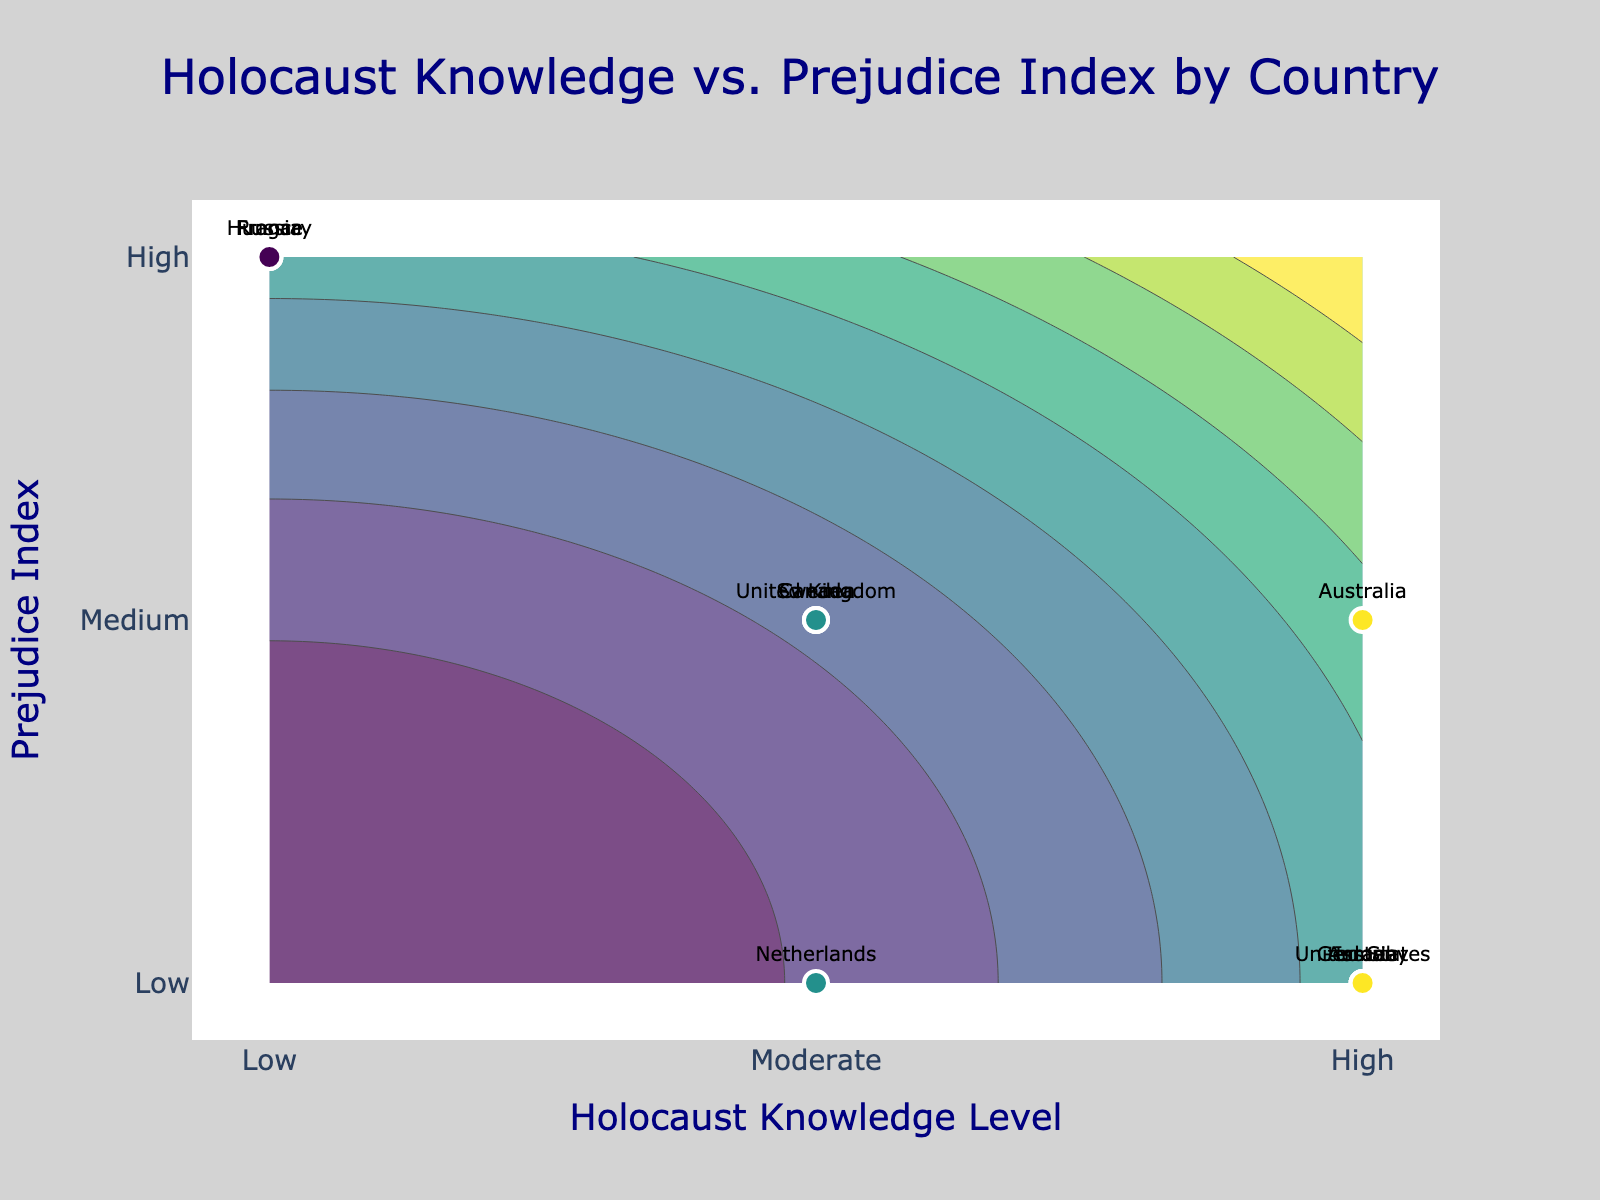What is the title of the figure? The title of the figure is shown at the top center of the plot.
Answer: Holocaust Knowledge vs. Prejudice Index by Country How many countries are displayed in the figure? Each data point represents a country. By counting the number of data points labeled with country names, we can determine the number of countries.
Answer: 12 Which country has the highest Holocaust Knowledge level? The Holocaust Knowledge level is mapped to the x-axis and can be "Low" (0), "Moderate" (1.5), or "High" (3). The country with a data point at "High" or x=3 represents the highest knowledge level.
Answer: United States, Germany, Israel, Austria, Australia Which country has the highest Prejudice Index? The Prejudice Index is mapped to the y-axis and can be "Low" (0), "Medium" (1.5), or "High" (3). The country with a data point at "High" or y=3 represents the highest prejudice index.
Answer: France, Russia, Hungary Which countries have both Holocaust Knowledge and Prejudice Index at medium levels? The medium level for both axes is represented by a numeric value of 1.5. Countries that have data points at (1.5, 1.5) fall into this category.
Answer: United Kingdom, Canada, Sweden How does the Prejudice Index for Russia compare to that of the Netherlands? Russia's Prejudice Index can be found by locating its position on the y-axis, which is "High" (3). The Netherlands' Prejudice Index is "Low" (0). Thus, Russia has a higher Prejudice Index.
Answer: Russia > Netherlands What general trend can you observe between Holocaust Knowledge and the Prejudice Index? By looking at the scatter plot, if most of the points with higher knowledge (towards the right) have lower prejudice (towards the bottom), it suggests a negative correlation between knowledge and prejudice.
Answer: Negative correlation Which country has "Moderate" Holocaust Knowledge but "Low" Prejudice Index? The Holocaust Knowledge level of "Moderate" corresponds to x=1.5, and "Low" Prejudice Index corresponds to y=0. The country with a data point at (1.5, 0) is the one we are looking for.
Answer: Netherlands 